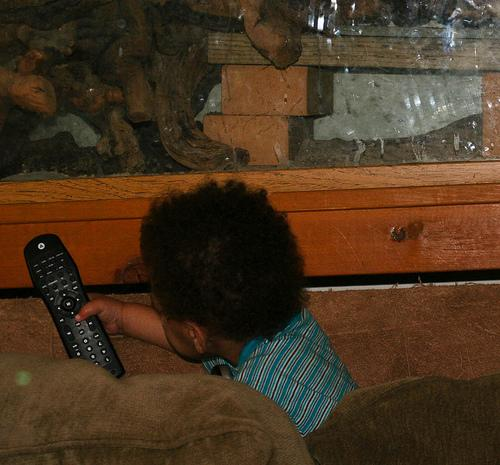What is the glass container likely to be?

Choices:
A) bookshelf
B) tv stand
C) fish tank
D) china cabinet fish tank 